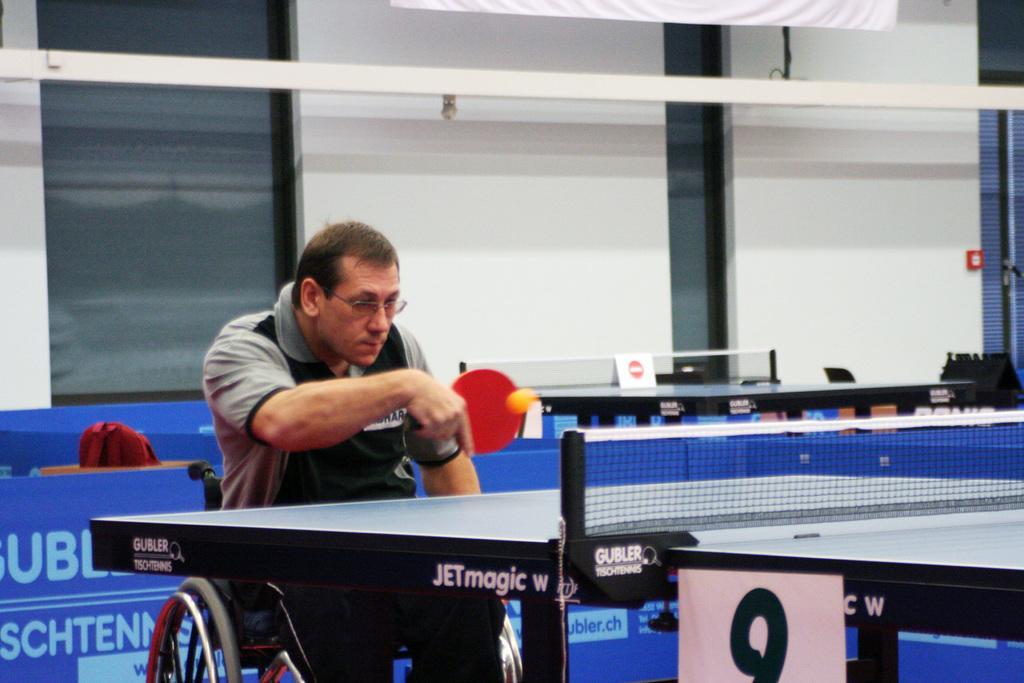In one or two sentences, can you explain what this image depicts? In this picture we can see a man sitting on the wheelchair holding the bat in front of the table and behind him there are the windows and the other tables. 